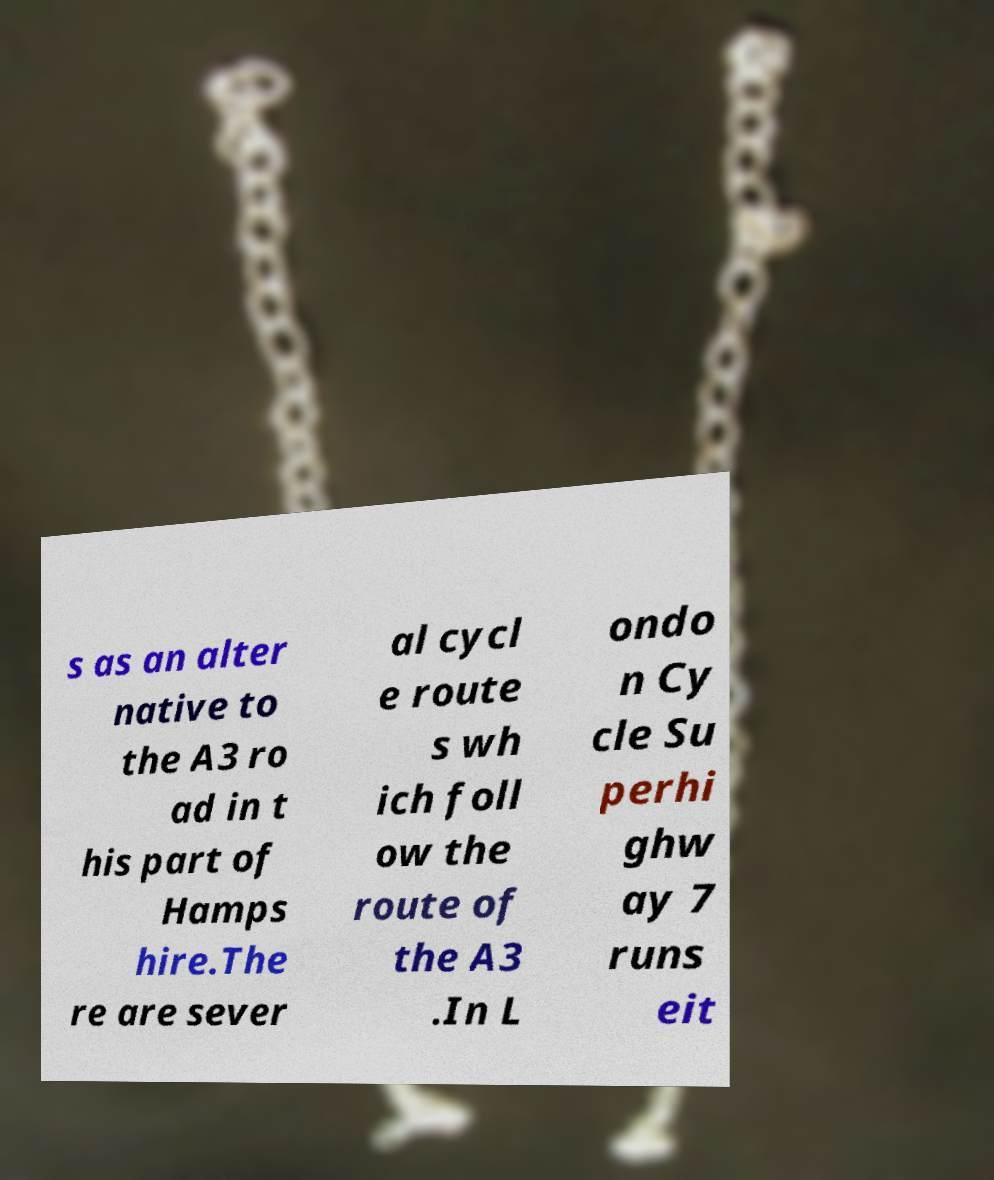Could you assist in decoding the text presented in this image and type it out clearly? s as an alter native to the A3 ro ad in t his part of Hamps hire.The re are sever al cycl e route s wh ich foll ow the route of the A3 .In L ondo n Cy cle Su perhi ghw ay 7 runs eit 